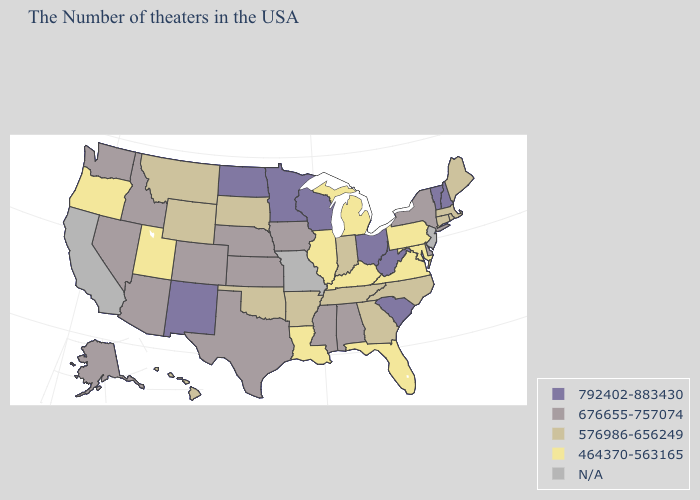What is the lowest value in the West?
Short answer required. 464370-563165. Does the first symbol in the legend represent the smallest category?
Quick response, please. No. Name the states that have a value in the range 464370-563165?
Answer briefly. Maryland, Pennsylvania, Virginia, Florida, Michigan, Kentucky, Illinois, Louisiana, Utah, Oregon. Name the states that have a value in the range 676655-757074?
Write a very short answer. New York, Delaware, Alabama, Mississippi, Iowa, Kansas, Nebraska, Texas, Colorado, Arizona, Idaho, Nevada, Washington, Alaska. What is the highest value in the USA?
Short answer required. 792402-883430. Name the states that have a value in the range 464370-563165?
Give a very brief answer. Maryland, Pennsylvania, Virginia, Florida, Michigan, Kentucky, Illinois, Louisiana, Utah, Oregon. Among the states that border New Jersey , does Delaware have the lowest value?
Quick response, please. No. Name the states that have a value in the range 676655-757074?
Quick response, please. New York, Delaware, Alabama, Mississippi, Iowa, Kansas, Nebraska, Texas, Colorado, Arizona, Idaho, Nevada, Washington, Alaska. What is the value of Indiana?
Concise answer only. 576986-656249. How many symbols are there in the legend?
Concise answer only. 5. What is the highest value in states that border Iowa?
Keep it brief. 792402-883430. Among the states that border New Jersey , does Pennsylvania have the lowest value?
Be succinct. Yes. What is the value of Wisconsin?
Answer briefly. 792402-883430. Among the states that border Mississippi , does Louisiana have the highest value?
Keep it brief. No. What is the lowest value in the USA?
Short answer required. 464370-563165. 